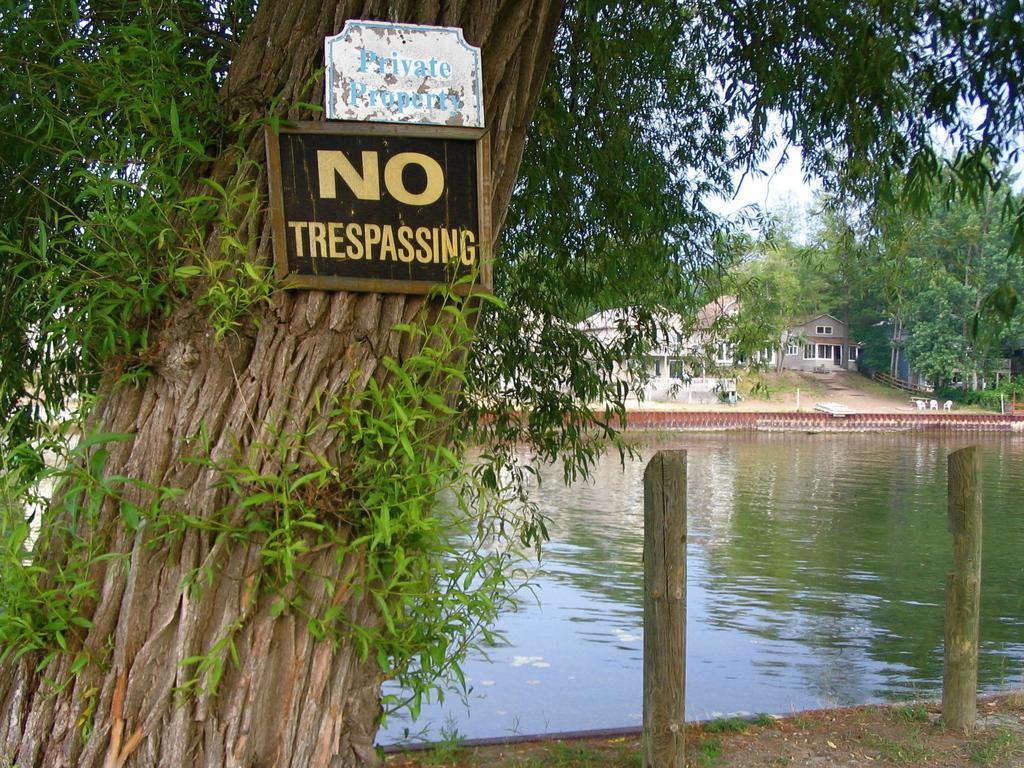How would you summarize this image in a sentence or two? In this image we can see a few houses, there are some trees, water, boards with some text and poles, in the background we can see the sky. 